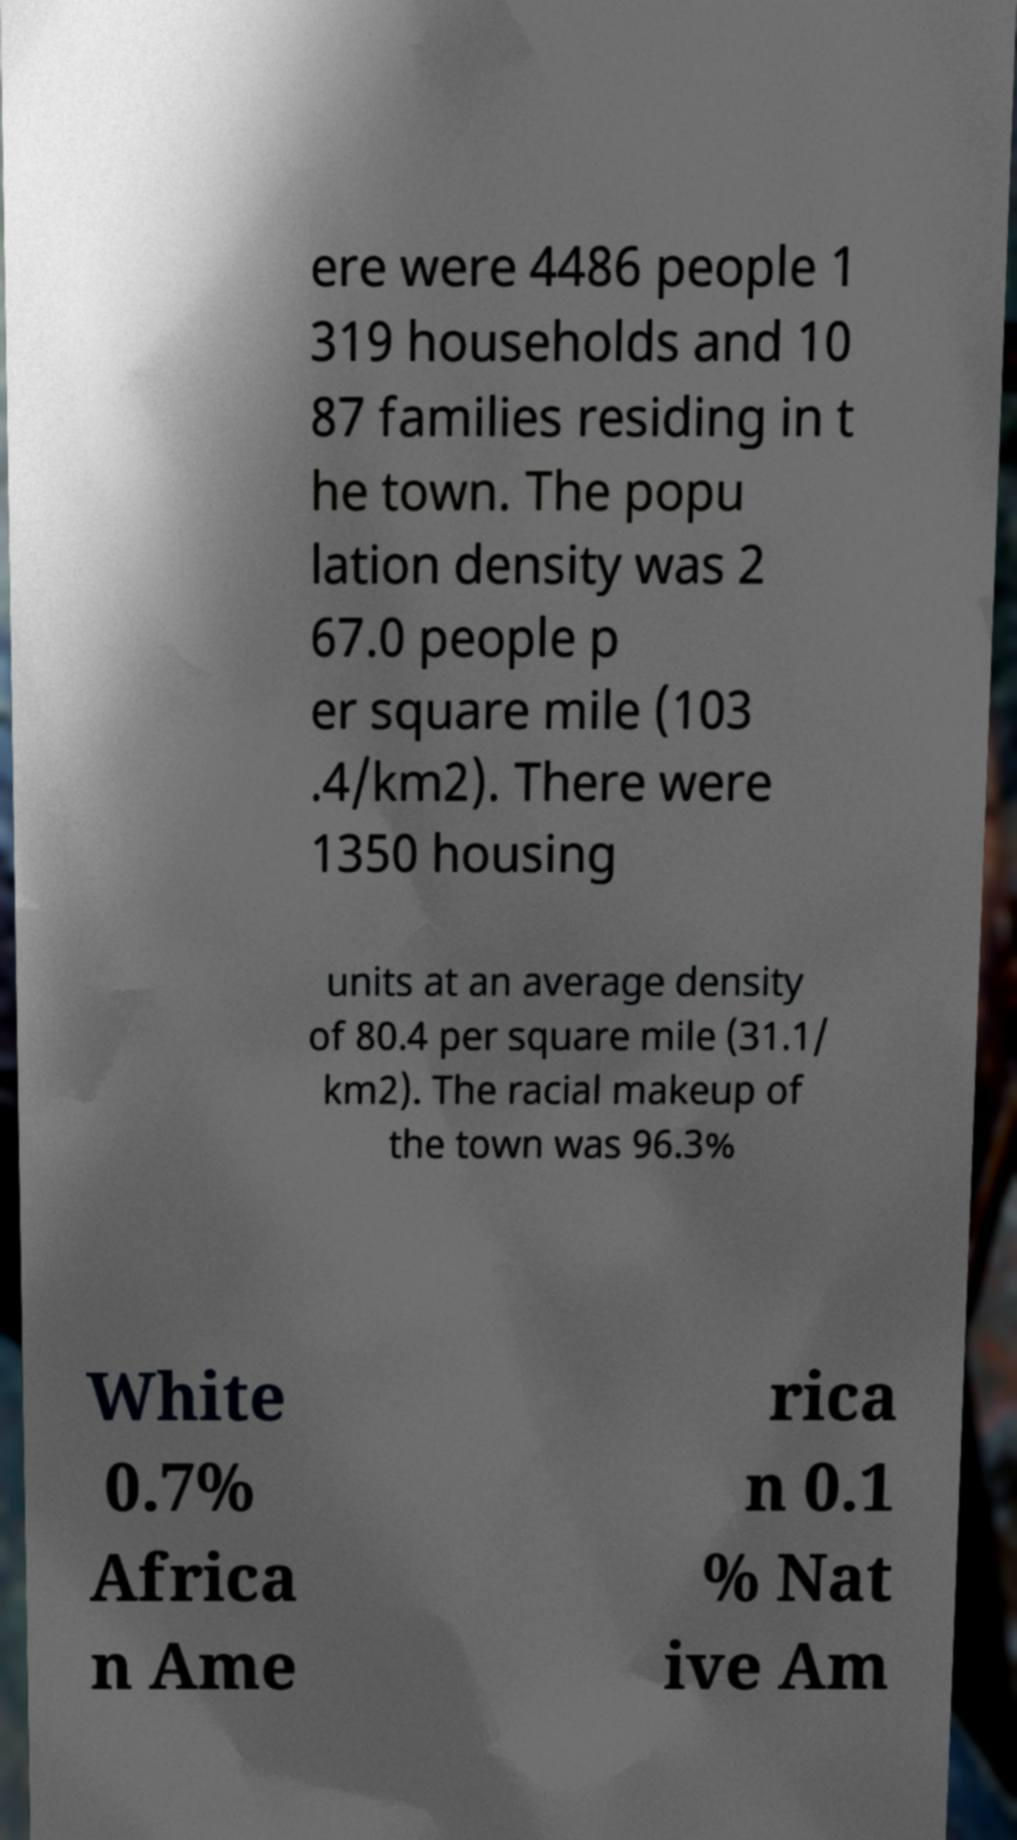Can you read and provide the text displayed in the image?This photo seems to have some interesting text. Can you extract and type it out for me? ere were 4486 people 1 319 households and 10 87 families residing in t he town. The popu lation density was 2 67.0 people p er square mile (103 .4/km2). There were 1350 housing units at an average density of 80.4 per square mile (31.1/ km2). The racial makeup of the town was 96.3% White 0.7% Africa n Ame rica n 0.1 % Nat ive Am 